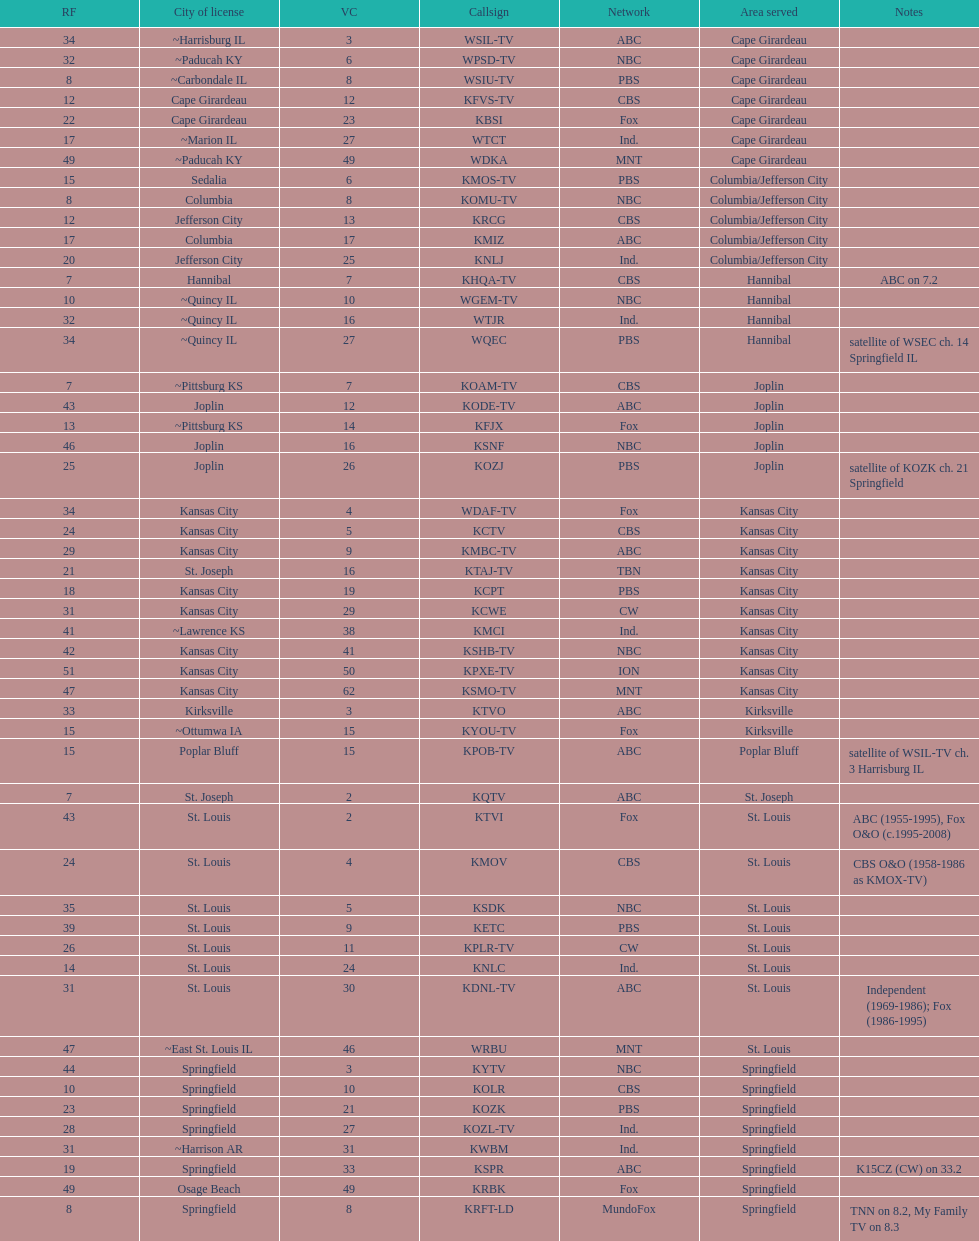I'm looking to parse the entire table for insights. Could you assist me with that? {'header': ['RF', 'City of license', 'VC', 'Callsign', 'Network', 'Area served', 'Notes'], 'rows': [['34', '~Harrisburg IL', '3', 'WSIL-TV', 'ABC', 'Cape Girardeau', ''], ['32', '~Paducah KY', '6', 'WPSD-TV', 'NBC', 'Cape Girardeau', ''], ['8', '~Carbondale IL', '8', 'WSIU-TV', 'PBS', 'Cape Girardeau', ''], ['12', 'Cape Girardeau', '12', 'KFVS-TV', 'CBS', 'Cape Girardeau', ''], ['22', 'Cape Girardeau', '23', 'KBSI', 'Fox', 'Cape Girardeau', ''], ['17', '~Marion IL', '27', 'WTCT', 'Ind.', 'Cape Girardeau', ''], ['49', '~Paducah KY', '49', 'WDKA', 'MNT', 'Cape Girardeau', ''], ['15', 'Sedalia', '6', 'KMOS-TV', 'PBS', 'Columbia/Jefferson City', ''], ['8', 'Columbia', '8', 'KOMU-TV', 'NBC', 'Columbia/Jefferson City', ''], ['12', 'Jefferson City', '13', 'KRCG', 'CBS', 'Columbia/Jefferson City', ''], ['17', 'Columbia', '17', 'KMIZ', 'ABC', 'Columbia/Jefferson City', ''], ['20', 'Jefferson City', '25', 'KNLJ', 'Ind.', 'Columbia/Jefferson City', ''], ['7', 'Hannibal', '7', 'KHQA-TV', 'CBS', 'Hannibal', 'ABC on 7.2'], ['10', '~Quincy IL', '10', 'WGEM-TV', 'NBC', 'Hannibal', ''], ['32', '~Quincy IL', '16', 'WTJR', 'Ind.', 'Hannibal', ''], ['34', '~Quincy IL', '27', 'WQEC', 'PBS', 'Hannibal', 'satellite of WSEC ch. 14 Springfield IL'], ['7', '~Pittsburg KS', '7', 'KOAM-TV', 'CBS', 'Joplin', ''], ['43', 'Joplin', '12', 'KODE-TV', 'ABC', 'Joplin', ''], ['13', '~Pittsburg KS', '14', 'KFJX', 'Fox', 'Joplin', ''], ['46', 'Joplin', '16', 'KSNF', 'NBC', 'Joplin', ''], ['25', 'Joplin', '26', 'KOZJ', 'PBS', 'Joplin', 'satellite of KOZK ch. 21 Springfield'], ['34', 'Kansas City', '4', 'WDAF-TV', 'Fox', 'Kansas City', ''], ['24', 'Kansas City', '5', 'KCTV', 'CBS', 'Kansas City', ''], ['29', 'Kansas City', '9', 'KMBC-TV', 'ABC', 'Kansas City', ''], ['21', 'St. Joseph', '16', 'KTAJ-TV', 'TBN', 'Kansas City', ''], ['18', 'Kansas City', '19', 'KCPT', 'PBS', 'Kansas City', ''], ['31', 'Kansas City', '29', 'KCWE', 'CW', 'Kansas City', ''], ['41', '~Lawrence KS', '38', 'KMCI', 'Ind.', 'Kansas City', ''], ['42', 'Kansas City', '41', 'KSHB-TV', 'NBC', 'Kansas City', ''], ['51', 'Kansas City', '50', 'KPXE-TV', 'ION', 'Kansas City', ''], ['47', 'Kansas City', '62', 'KSMO-TV', 'MNT', 'Kansas City', ''], ['33', 'Kirksville', '3', 'KTVO', 'ABC', 'Kirksville', ''], ['15', '~Ottumwa IA', '15', 'KYOU-TV', 'Fox', 'Kirksville', ''], ['15', 'Poplar Bluff', '15', 'KPOB-TV', 'ABC', 'Poplar Bluff', 'satellite of WSIL-TV ch. 3 Harrisburg IL'], ['7', 'St. Joseph', '2', 'KQTV', 'ABC', 'St. Joseph', ''], ['43', 'St. Louis', '2', 'KTVI', 'Fox', 'St. Louis', 'ABC (1955-1995), Fox O&O (c.1995-2008)'], ['24', 'St. Louis', '4', 'KMOV', 'CBS', 'St. Louis', 'CBS O&O (1958-1986 as KMOX-TV)'], ['35', 'St. Louis', '5', 'KSDK', 'NBC', 'St. Louis', ''], ['39', 'St. Louis', '9', 'KETC', 'PBS', 'St. Louis', ''], ['26', 'St. Louis', '11', 'KPLR-TV', 'CW', 'St. Louis', ''], ['14', 'St. Louis', '24', 'KNLC', 'Ind.', 'St. Louis', ''], ['31', 'St. Louis', '30', 'KDNL-TV', 'ABC', 'St. Louis', 'Independent (1969-1986); Fox (1986-1995)'], ['47', '~East St. Louis IL', '46', 'WRBU', 'MNT', 'St. Louis', ''], ['44', 'Springfield', '3', 'KYTV', 'NBC', 'Springfield', ''], ['10', 'Springfield', '10', 'KOLR', 'CBS', 'Springfield', ''], ['23', 'Springfield', '21', 'KOZK', 'PBS', 'Springfield', ''], ['28', 'Springfield', '27', 'KOZL-TV', 'Ind.', 'Springfield', ''], ['31', '~Harrison AR', '31', 'KWBM', 'Ind.', 'Springfield', ''], ['19', 'Springfield', '33', 'KSPR', 'ABC', 'Springfield', 'K15CZ (CW) on 33.2'], ['49', 'Osage Beach', '49', 'KRBK', 'Fox', 'Springfield', ''], ['8', 'Springfield', '8', 'KRFT-LD', 'MundoFox', 'Springfield', 'TNN on 8.2, My Family TV on 8.3']]} How many of these missouri tv stations are actually licensed in a city in illinois (il)? 7. 